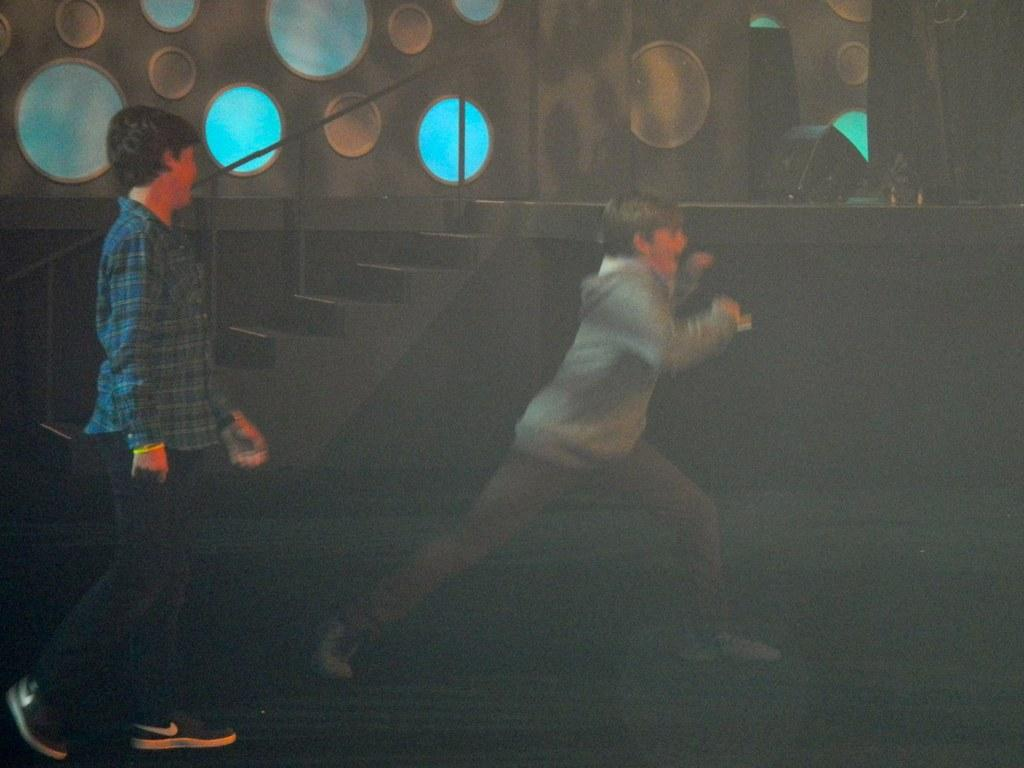How many people are in the image? There are two persons in the image. What is located behind the persons? There are stairs visible behind the persons. Can you describe the lighting in the image? There is light in the image. What type of structure is present in the image? There is a wall in the image. What can be seen on the wall? There are circular objects on the wall. How does the grass compare to the chain in the image? There is no grass or chain present in the image. 